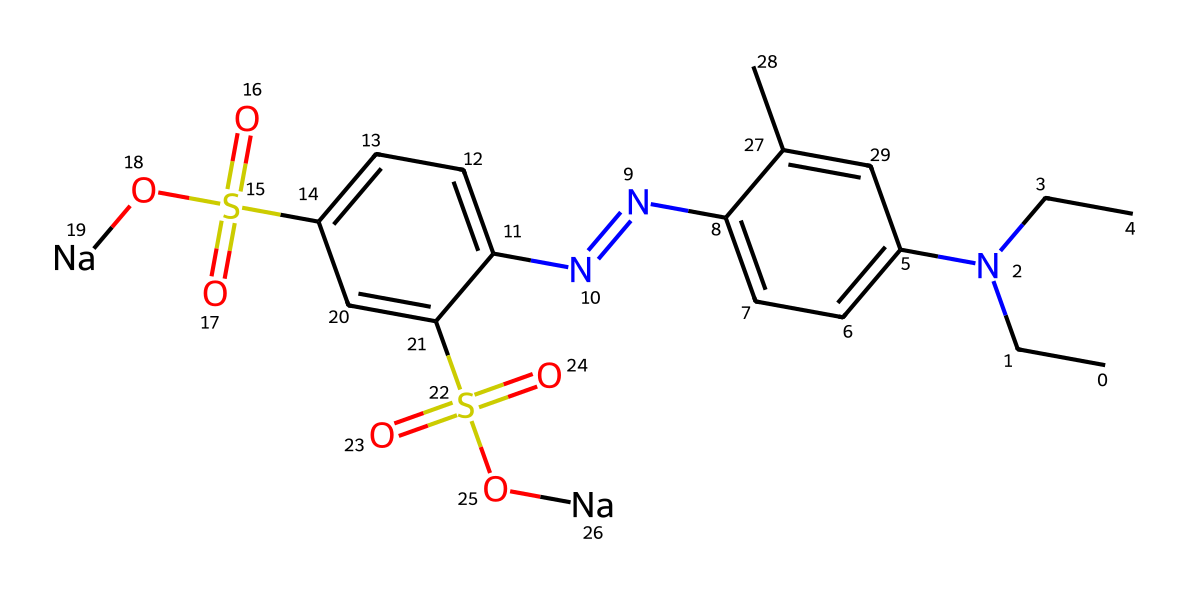What type of chemical is represented by this structure? This structure represents a dye, specifically an azo dye, which can be identified by the presence of the -N=N- group linking aromatic rings.
Answer: azo dye How many nitrogen atoms are in the structure? By examining the SMILES representation, we can see there are four nitrogen atoms (two in the azo group and two in the dimethylamine groups).
Answer: four What functional groups are present in this molecule? The functional groups visible in this structure are sulfonic acid groups (indicated by S(=O)(=O)O), and an azo group (-N=N-).
Answer: sulfonic acid, azo What is the significance of the sulfonic acid groups in the dye? The sulfonic acid groups increase the water solubility of the dye, which is crucial for its application in food coloring.
Answer: increase water solubility What is the primary color typically associated with azo dyes? Azo dyes can produce a range of colors, but many are associated with vibrant reds and oranges, depending on their specific structure and substituents.
Answer: red, orange How does the presence of sodium affect the dye's characteristics? The sodium ions from the sulfonic groups act to stabilize the dye in solution, enhancing its usability in baking as a food coloring agent.
Answer: stabilization 